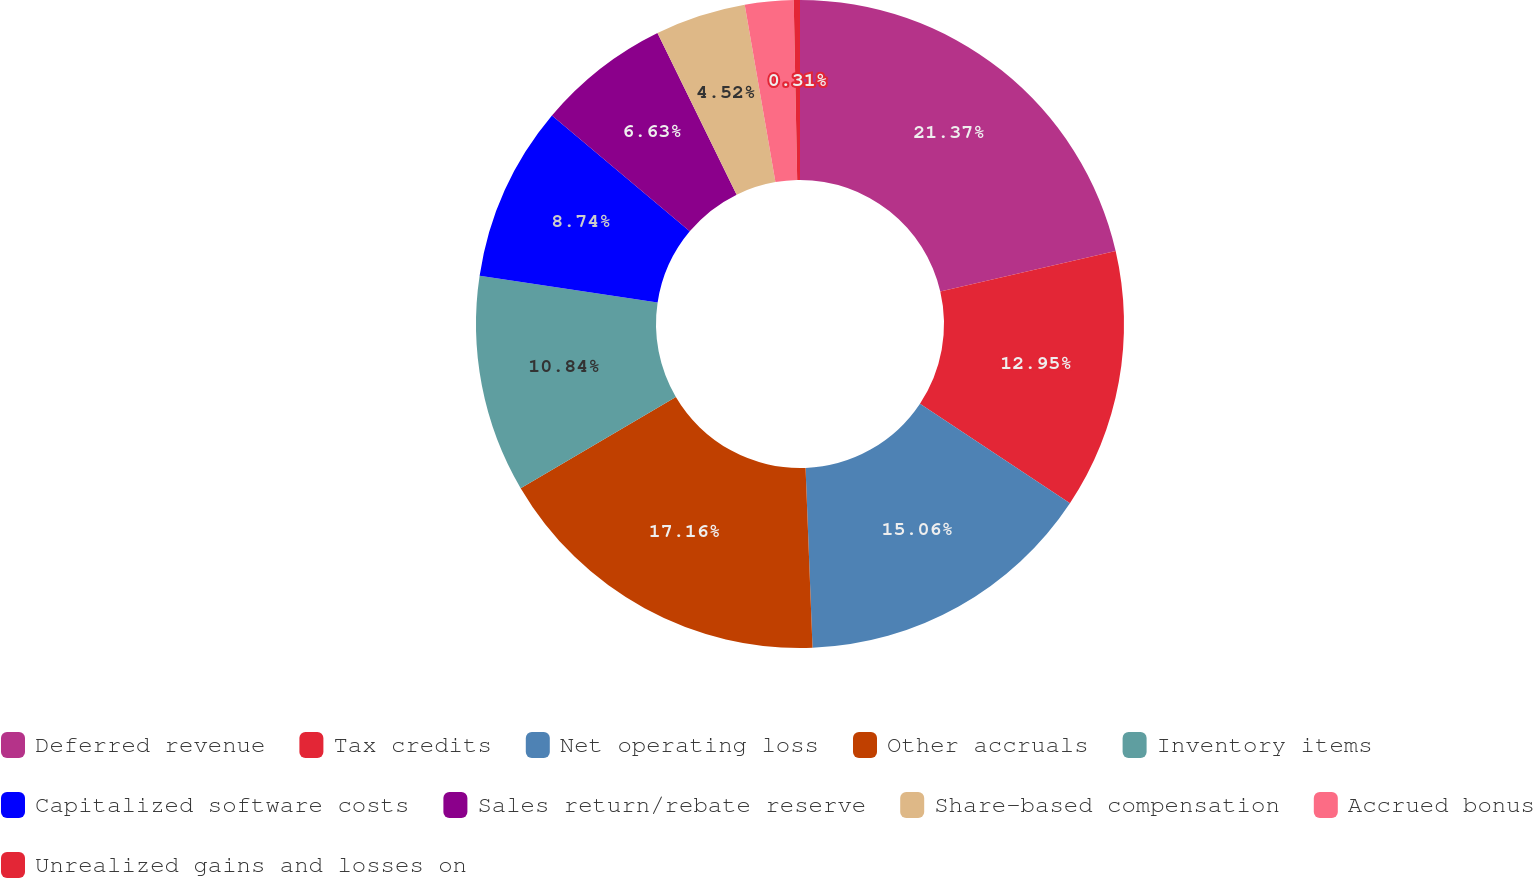Convert chart to OTSL. <chart><loc_0><loc_0><loc_500><loc_500><pie_chart><fcel>Deferred revenue<fcel>Tax credits<fcel>Net operating loss<fcel>Other accruals<fcel>Inventory items<fcel>Capitalized software costs<fcel>Sales return/rebate reserve<fcel>Share-based compensation<fcel>Accrued bonus<fcel>Unrealized gains and losses on<nl><fcel>21.38%<fcel>12.95%<fcel>15.06%<fcel>17.16%<fcel>10.84%<fcel>8.74%<fcel>6.63%<fcel>4.52%<fcel>2.42%<fcel>0.31%<nl></chart> 